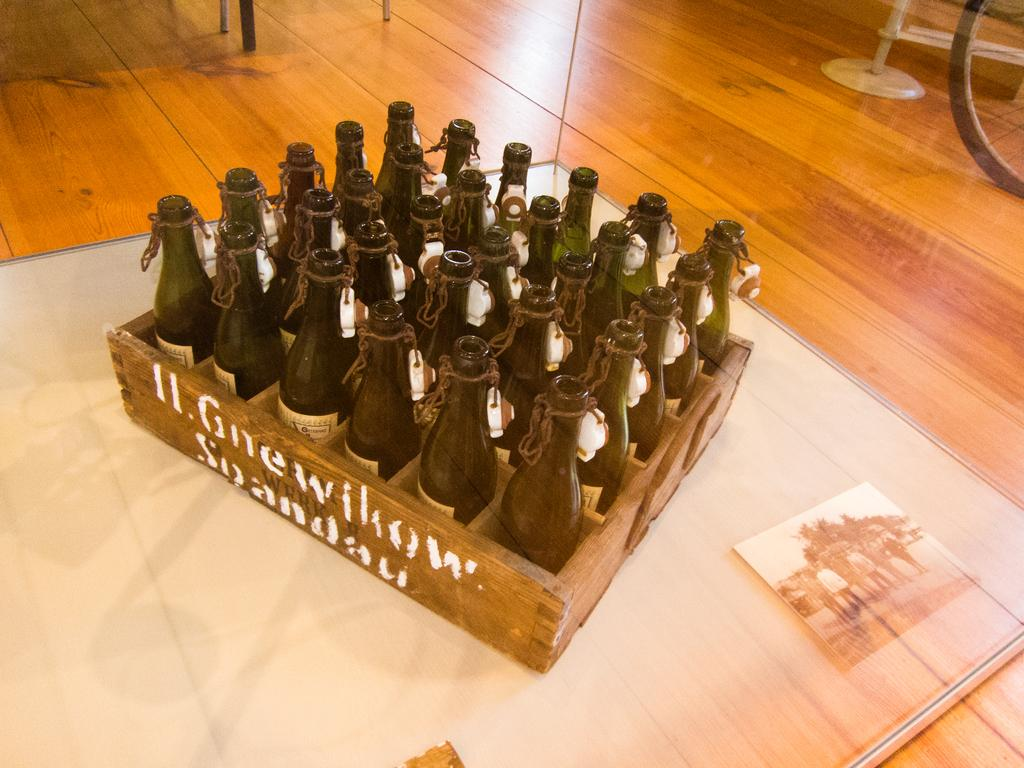Provide a one-sentence caption for the provided image. An old crate labeled Gnewillow is filled with empty bottles. 